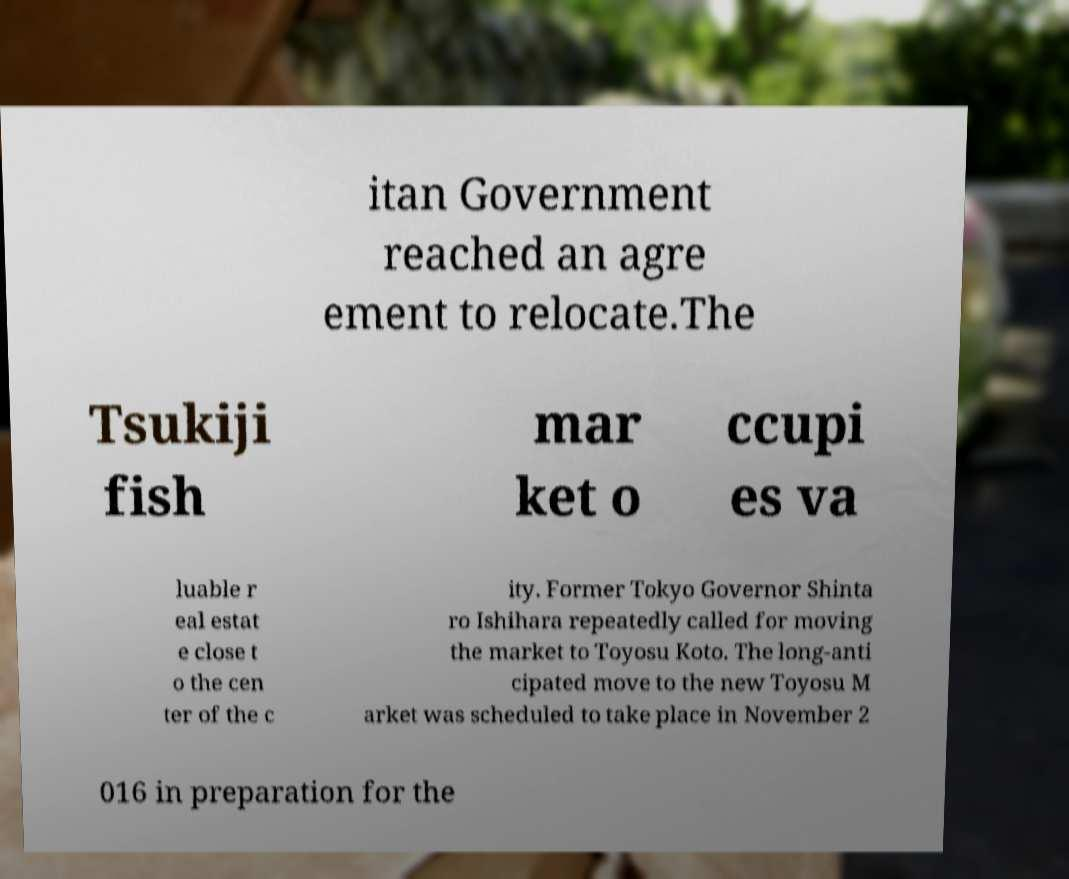Please identify and transcribe the text found in this image. itan Government reached an agre ement to relocate.The Tsukiji fish mar ket o ccupi es va luable r eal estat e close t o the cen ter of the c ity. Former Tokyo Governor Shinta ro Ishihara repeatedly called for moving the market to Toyosu Koto. The long-anti cipated move to the new Toyosu M arket was scheduled to take place in November 2 016 in preparation for the 